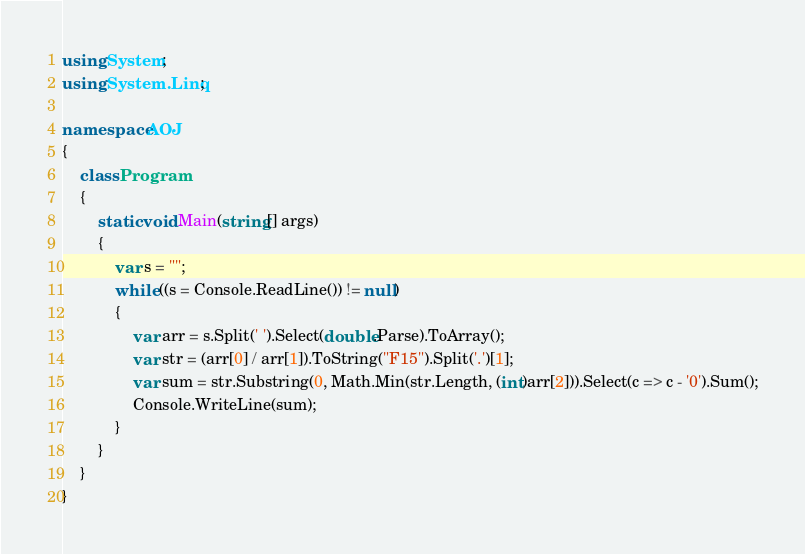<code> <loc_0><loc_0><loc_500><loc_500><_C#_>using System;
using System.Linq;

namespace AOJ
{
    class Program
    {
        static void Main(string[] args)
        {
            var s = "";
            while ((s = Console.ReadLine()) != null)
            {
                var arr = s.Split(' ').Select(double.Parse).ToArray();
                var str = (arr[0] / arr[1]).ToString("F15").Split('.')[1];
                var sum = str.Substring(0, Math.Min(str.Length, (int)arr[2])).Select(c => c - '0').Sum();
                Console.WriteLine(sum);
            }
        }
    }
}</code> 